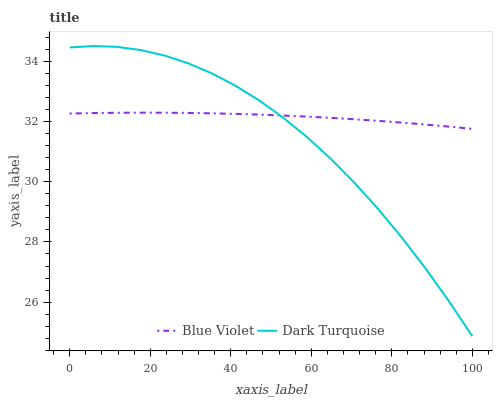Does Dark Turquoise have the minimum area under the curve?
Answer yes or no. Yes. Does Blue Violet have the maximum area under the curve?
Answer yes or no. Yes. Does Blue Violet have the minimum area under the curve?
Answer yes or no. No. Is Blue Violet the smoothest?
Answer yes or no. Yes. Is Dark Turquoise the roughest?
Answer yes or no. Yes. Is Blue Violet the roughest?
Answer yes or no. No. Does Dark Turquoise have the lowest value?
Answer yes or no. Yes. Does Blue Violet have the lowest value?
Answer yes or no. No. Does Dark Turquoise have the highest value?
Answer yes or no. Yes. Does Blue Violet have the highest value?
Answer yes or no. No. Does Blue Violet intersect Dark Turquoise?
Answer yes or no. Yes. Is Blue Violet less than Dark Turquoise?
Answer yes or no. No. Is Blue Violet greater than Dark Turquoise?
Answer yes or no. No. 